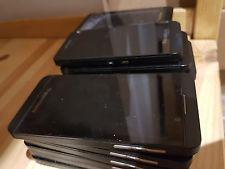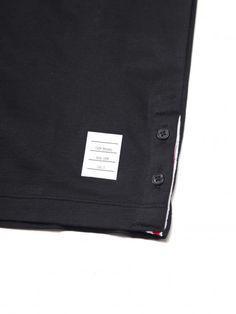The first image is the image on the left, the second image is the image on the right. For the images displayed, is the sentence "Cell phones are lined in two lines on a surface in the image on the right." factually correct? Answer yes or no. No. The first image is the image on the left, the second image is the image on the right. For the images displayed, is the sentence "The right image contains two horizontal rows of cell phones." factually correct? Answer yes or no. No. 